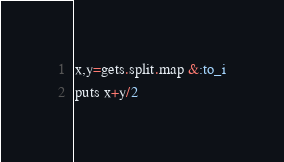Convert code to text. <code><loc_0><loc_0><loc_500><loc_500><_Ruby_>x,y=gets.split.map &:to_i
puts x+y/2
</code> 